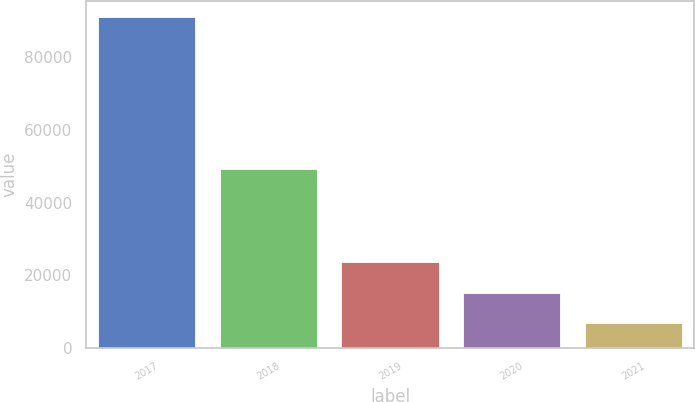<chart> <loc_0><loc_0><loc_500><loc_500><bar_chart><fcel>2017<fcel>2018<fcel>2019<fcel>2020<fcel>2021<nl><fcel>91003<fcel>49133<fcel>23600.6<fcel>15175.3<fcel>6750<nl></chart> 